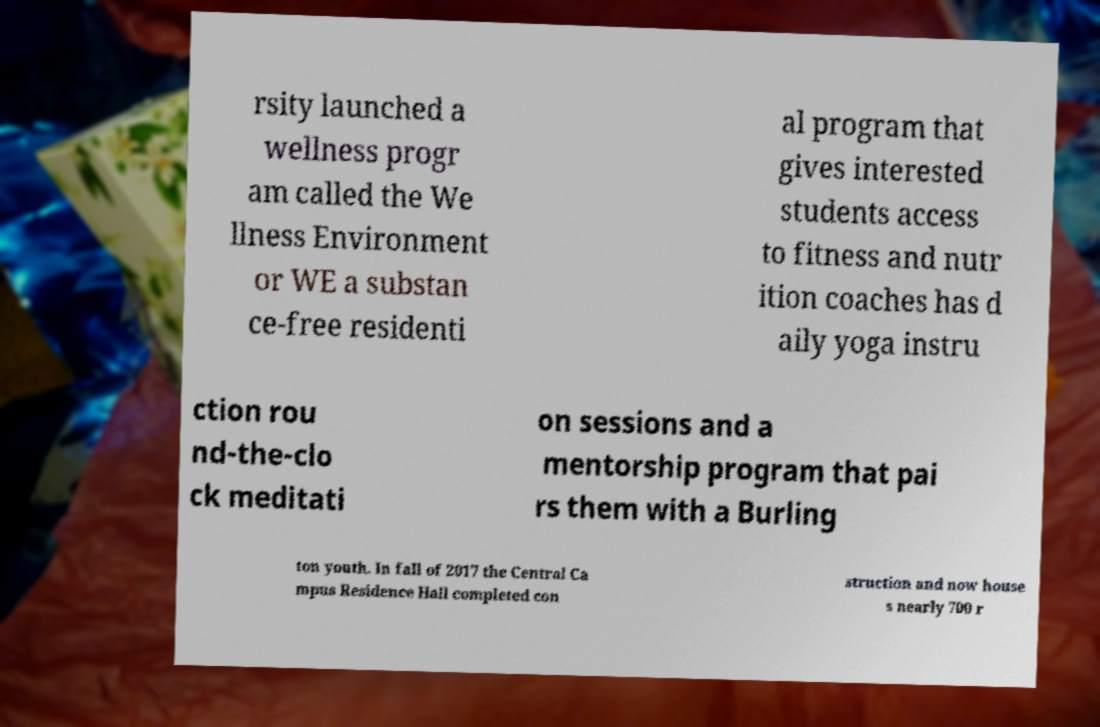Can you accurately transcribe the text from the provided image for me? rsity launched a wellness progr am called the We llness Environment or WE a substan ce-free residenti al program that gives interested students access to fitness and nutr ition coaches has d aily yoga instru ction rou nd-the-clo ck meditati on sessions and a mentorship program that pai rs them with a Burling ton youth. In fall of 2017 the Central Ca mpus Residence Hall completed con struction and now house s nearly 700 r 